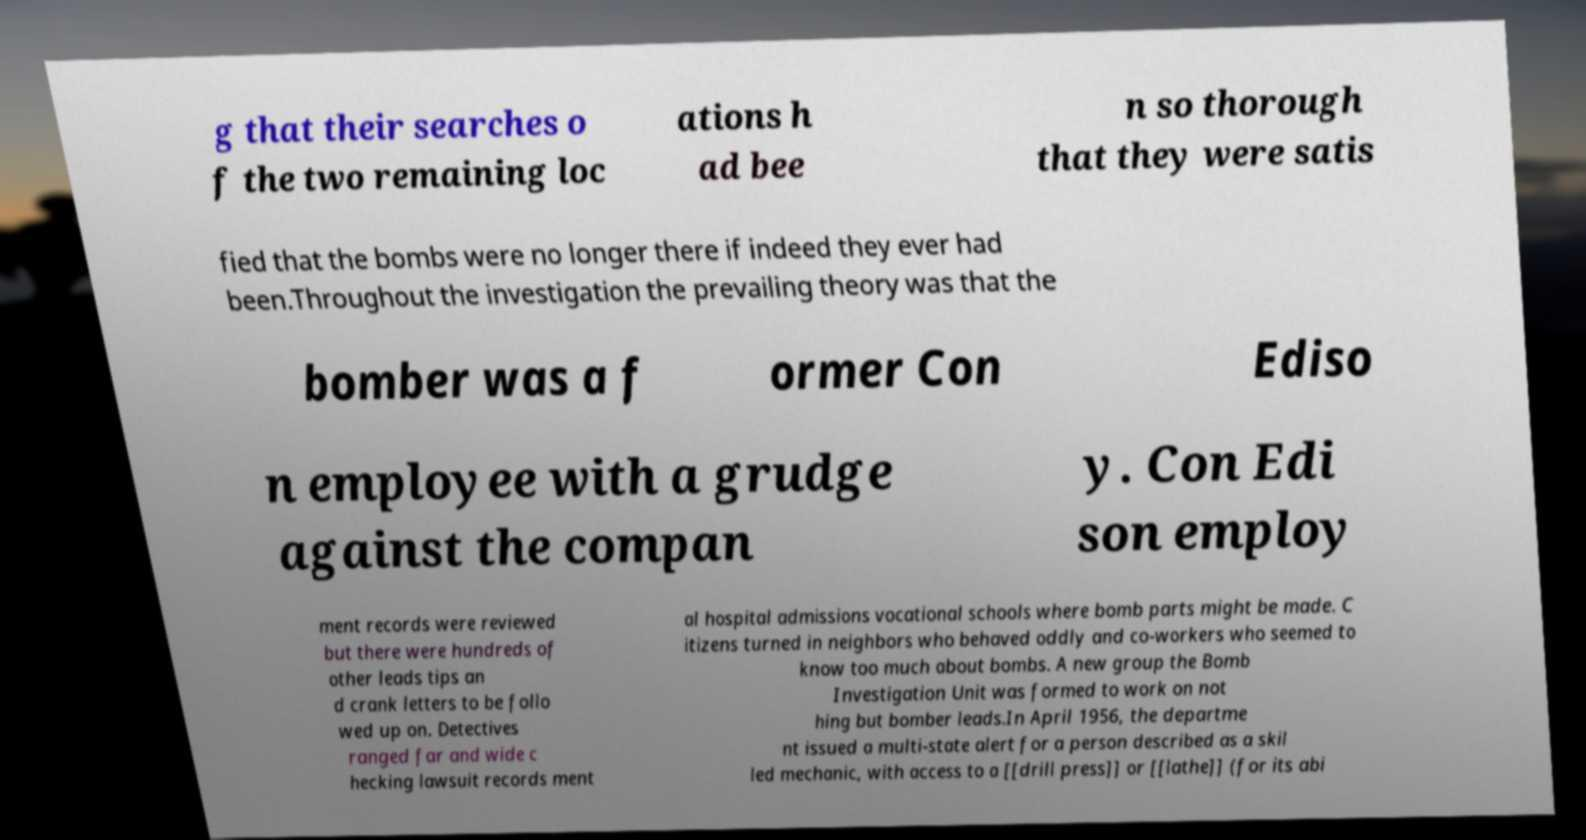Could you extract and type out the text from this image? g that their searches o f the two remaining loc ations h ad bee n so thorough that they were satis fied that the bombs were no longer there if indeed they ever had been.Throughout the investigation the prevailing theory was that the bomber was a f ormer Con Ediso n employee with a grudge against the compan y. Con Edi son employ ment records were reviewed but there were hundreds of other leads tips an d crank letters to be follo wed up on. Detectives ranged far and wide c hecking lawsuit records ment al hospital admissions vocational schools where bomb parts might be made. C itizens turned in neighbors who behaved oddly and co-workers who seemed to know too much about bombs. A new group the Bomb Investigation Unit was formed to work on not hing but bomber leads.In April 1956, the departme nt issued a multi-state alert for a person described as a skil led mechanic, with access to a [[drill press]] or [[lathe]] (for its abi 